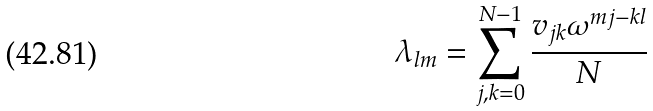<formula> <loc_0><loc_0><loc_500><loc_500>\lambda _ { l m } = \sum _ { j , k = 0 } ^ { N - 1 } \frac { v _ { j k } \omega ^ { m j - k l } } { N }</formula> 